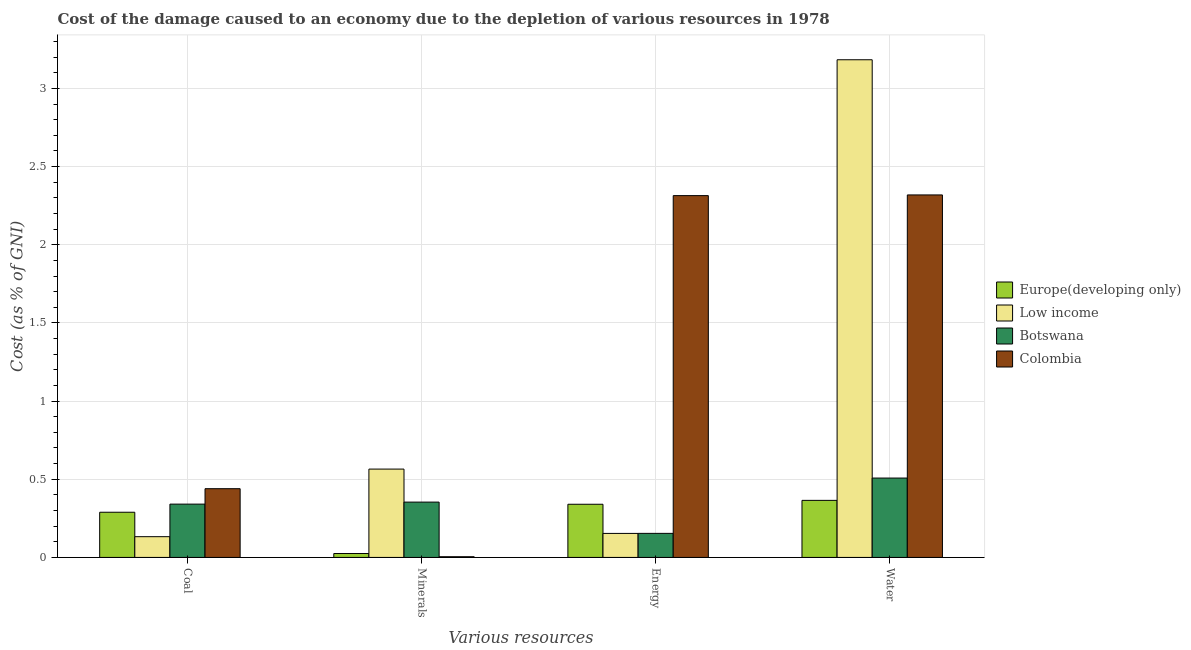How many groups of bars are there?
Offer a terse response. 4. Are the number of bars on each tick of the X-axis equal?
Your response must be concise. Yes. How many bars are there on the 4th tick from the right?
Provide a short and direct response. 4. What is the label of the 1st group of bars from the left?
Your response must be concise. Coal. What is the cost of damage due to depletion of energy in Low income?
Provide a succinct answer. 0.15. Across all countries, what is the maximum cost of damage due to depletion of water?
Provide a short and direct response. 3.18. Across all countries, what is the minimum cost of damage due to depletion of energy?
Provide a short and direct response. 0.15. In which country was the cost of damage due to depletion of energy maximum?
Ensure brevity in your answer.  Colombia. In which country was the cost of damage due to depletion of water minimum?
Provide a succinct answer. Europe(developing only). What is the total cost of damage due to depletion of coal in the graph?
Your answer should be very brief. 1.2. What is the difference between the cost of damage due to depletion of water in Botswana and that in Colombia?
Make the answer very short. -1.81. What is the difference between the cost of damage due to depletion of energy in Low income and the cost of damage due to depletion of coal in Europe(developing only)?
Keep it short and to the point. -0.14. What is the average cost of damage due to depletion of minerals per country?
Give a very brief answer. 0.24. What is the difference between the cost of damage due to depletion of water and cost of damage due to depletion of coal in Colombia?
Offer a terse response. 1.88. In how many countries, is the cost of damage due to depletion of energy greater than 1.1 %?
Provide a short and direct response. 1. What is the ratio of the cost of damage due to depletion of energy in Botswana to that in Colombia?
Your response must be concise. 0.07. Is the difference between the cost of damage due to depletion of minerals in Botswana and Europe(developing only) greater than the difference between the cost of damage due to depletion of water in Botswana and Europe(developing only)?
Your response must be concise. Yes. What is the difference between the highest and the second highest cost of damage due to depletion of water?
Offer a very short reply. 0.86. What is the difference between the highest and the lowest cost of damage due to depletion of energy?
Your answer should be compact. 2.16. In how many countries, is the cost of damage due to depletion of minerals greater than the average cost of damage due to depletion of minerals taken over all countries?
Provide a short and direct response. 2. What does the 3rd bar from the left in Water represents?
Your answer should be very brief. Botswana. What does the 2nd bar from the right in Water represents?
Make the answer very short. Botswana. Is it the case that in every country, the sum of the cost of damage due to depletion of coal and cost of damage due to depletion of minerals is greater than the cost of damage due to depletion of energy?
Offer a very short reply. No. How many bars are there?
Offer a terse response. 16. Are all the bars in the graph horizontal?
Make the answer very short. No. Does the graph contain any zero values?
Your answer should be compact. No. Does the graph contain grids?
Your answer should be very brief. Yes. Where does the legend appear in the graph?
Offer a terse response. Center right. How many legend labels are there?
Your answer should be very brief. 4. How are the legend labels stacked?
Your answer should be compact. Vertical. What is the title of the graph?
Provide a short and direct response. Cost of the damage caused to an economy due to the depletion of various resources in 1978 . What is the label or title of the X-axis?
Keep it short and to the point. Various resources. What is the label or title of the Y-axis?
Give a very brief answer. Cost (as % of GNI). What is the Cost (as % of GNI) of Europe(developing only) in Coal?
Your answer should be compact. 0.29. What is the Cost (as % of GNI) of Low income in Coal?
Your answer should be compact. 0.13. What is the Cost (as % of GNI) of Botswana in Coal?
Provide a short and direct response. 0.34. What is the Cost (as % of GNI) in Colombia in Coal?
Make the answer very short. 0.44. What is the Cost (as % of GNI) of Europe(developing only) in Minerals?
Provide a short and direct response. 0.02. What is the Cost (as % of GNI) of Low income in Minerals?
Provide a short and direct response. 0.57. What is the Cost (as % of GNI) of Botswana in Minerals?
Provide a short and direct response. 0.35. What is the Cost (as % of GNI) of Colombia in Minerals?
Your answer should be compact. 0. What is the Cost (as % of GNI) in Europe(developing only) in Energy?
Provide a short and direct response. 0.34. What is the Cost (as % of GNI) of Low income in Energy?
Offer a terse response. 0.15. What is the Cost (as % of GNI) of Botswana in Energy?
Offer a very short reply. 0.15. What is the Cost (as % of GNI) of Colombia in Energy?
Give a very brief answer. 2.31. What is the Cost (as % of GNI) of Europe(developing only) in Water?
Make the answer very short. 0.37. What is the Cost (as % of GNI) in Low income in Water?
Keep it short and to the point. 3.18. What is the Cost (as % of GNI) of Botswana in Water?
Your answer should be compact. 0.51. What is the Cost (as % of GNI) of Colombia in Water?
Provide a short and direct response. 2.32. Across all Various resources, what is the maximum Cost (as % of GNI) of Europe(developing only)?
Your answer should be very brief. 0.37. Across all Various resources, what is the maximum Cost (as % of GNI) of Low income?
Make the answer very short. 3.18. Across all Various resources, what is the maximum Cost (as % of GNI) of Botswana?
Provide a short and direct response. 0.51. Across all Various resources, what is the maximum Cost (as % of GNI) in Colombia?
Give a very brief answer. 2.32. Across all Various resources, what is the minimum Cost (as % of GNI) in Europe(developing only)?
Keep it short and to the point. 0.02. Across all Various resources, what is the minimum Cost (as % of GNI) in Low income?
Provide a succinct answer. 0.13. Across all Various resources, what is the minimum Cost (as % of GNI) in Botswana?
Offer a terse response. 0.15. Across all Various resources, what is the minimum Cost (as % of GNI) of Colombia?
Your response must be concise. 0. What is the total Cost (as % of GNI) of Europe(developing only) in the graph?
Offer a very short reply. 1.02. What is the total Cost (as % of GNI) of Low income in the graph?
Your answer should be very brief. 4.03. What is the total Cost (as % of GNI) in Botswana in the graph?
Ensure brevity in your answer.  1.36. What is the total Cost (as % of GNI) in Colombia in the graph?
Provide a short and direct response. 5.08. What is the difference between the Cost (as % of GNI) in Europe(developing only) in Coal and that in Minerals?
Your answer should be very brief. 0.26. What is the difference between the Cost (as % of GNI) of Low income in Coal and that in Minerals?
Make the answer very short. -0.43. What is the difference between the Cost (as % of GNI) in Botswana in Coal and that in Minerals?
Keep it short and to the point. -0.01. What is the difference between the Cost (as % of GNI) in Colombia in Coal and that in Minerals?
Give a very brief answer. 0.44. What is the difference between the Cost (as % of GNI) in Europe(developing only) in Coal and that in Energy?
Offer a very short reply. -0.05. What is the difference between the Cost (as % of GNI) of Low income in Coal and that in Energy?
Keep it short and to the point. -0.02. What is the difference between the Cost (as % of GNI) of Botswana in Coal and that in Energy?
Your answer should be very brief. 0.19. What is the difference between the Cost (as % of GNI) of Colombia in Coal and that in Energy?
Your answer should be very brief. -1.87. What is the difference between the Cost (as % of GNI) of Europe(developing only) in Coal and that in Water?
Provide a short and direct response. -0.08. What is the difference between the Cost (as % of GNI) in Low income in Coal and that in Water?
Your answer should be compact. -3.05. What is the difference between the Cost (as % of GNI) in Colombia in Coal and that in Water?
Ensure brevity in your answer.  -1.88. What is the difference between the Cost (as % of GNI) of Europe(developing only) in Minerals and that in Energy?
Ensure brevity in your answer.  -0.32. What is the difference between the Cost (as % of GNI) of Low income in Minerals and that in Energy?
Offer a terse response. 0.41. What is the difference between the Cost (as % of GNI) in Colombia in Minerals and that in Energy?
Make the answer very short. -2.31. What is the difference between the Cost (as % of GNI) in Europe(developing only) in Minerals and that in Water?
Your answer should be very brief. -0.34. What is the difference between the Cost (as % of GNI) in Low income in Minerals and that in Water?
Ensure brevity in your answer.  -2.62. What is the difference between the Cost (as % of GNI) in Botswana in Minerals and that in Water?
Your response must be concise. -0.15. What is the difference between the Cost (as % of GNI) of Colombia in Minerals and that in Water?
Keep it short and to the point. -2.31. What is the difference between the Cost (as % of GNI) in Europe(developing only) in Energy and that in Water?
Your answer should be very brief. -0.02. What is the difference between the Cost (as % of GNI) of Low income in Energy and that in Water?
Provide a succinct answer. -3.03. What is the difference between the Cost (as % of GNI) in Botswana in Energy and that in Water?
Your answer should be very brief. -0.35. What is the difference between the Cost (as % of GNI) of Colombia in Energy and that in Water?
Provide a succinct answer. -0. What is the difference between the Cost (as % of GNI) of Europe(developing only) in Coal and the Cost (as % of GNI) of Low income in Minerals?
Ensure brevity in your answer.  -0.28. What is the difference between the Cost (as % of GNI) in Europe(developing only) in Coal and the Cost (as % of GNI) in Botswana in Minerals?
Ensure brevity in your answer.  -0.06. What is the difference between the Cost (as % of GNI) in Europe(developing only) in Coal and the Cost (as % of GNI) in Colombia in Minerals?
Offer a terse response. 0.28. What is the difference between the Cost (as % of GNI) in Low income in Coal and the Cost (as % of GNI) in Botswana in Minerals?
Offer a terse response. -0.22. What is the difference between the Cost (as % of GNI) of Low income in Coal and the Cost (as % of GNI) of Colombia in Minerals?
Offer a terse response. 0.13. What is the difference between the Cost (as % of GNI) of Botswana in Coal and the Cost (as % of GNI) of Colombia in Minerals?
Your answer should be compact. 0.34. What is the difference between the Cost (as % of GNI) of Europe(developing only) in Coal and the Cost (as % of GNI) of Low income in Energy?
Give a very brief answer. 0.14. What is the difference between the Cost (as % of GNI) in Europe(developing only) in Coal and the Cost (as % of GNI) in Botswana in Energy?
Give a very brief answer. 0.14. What is the difference between the Cost (as % of GNI) of Europe(developing only) in Coal and the Cost (as % of GNI) of Colombia in Energy?
Your answer should be very brief. -2.03. What is the difference between the Cost (as % of GNI) of Low income in Coal and the Cost (as % of GNI) of Botswana in Energy?
Keep it short and to the point. -0.02. What is the difference between the Cost (as % of GNI) of Low income in Coal and the Cost (as % of GNI) of Colombia in Energy?
Provide a short and direct response. -2.18. What is the difference between the Cost (as % of GNI) in Botswana in Coal and the Cost (as % of GNI) in Colombia in Energy?
Offer a terse response. -1.97. What is the difference between the Cost (as % of GNI) of Europe(developing only) in Coal and the Cost (as % of GNI) of Low income in Water?
Give a very brief answer. -2.89. What is the difference between the Cost (as % of GNI) of Europe(developing only) in Coal and the Cost (as % of GNI) of Botswana in Water?
Provide a succinct answer. -0.22. What is the difference between the Cost (as % of GNI) in Europe(developing only) in Coal and the Cost (as % of GNI) in Colombia in Water?
Your response must be concise. -2.03. What is the difference between the Cost (as % of GNI) in Low income in Coal and the Cost (as % of GNI) in Botswana in Water?
Your response must be concise. -0.38. What is the difference between the Cost (as % of GNI) of Low income in Coal and the Cost (as % of GNI) of Colombia in Water?
Give a very brief answer. -2.19. What is the difference between the Cost (as % of GNI) of Botswana in Coal and the Cost (as % of GNI) of Colombia in Water?
Offer a very short reply. -1.98. What is the difference between the Cost (as % of GNI) in Europe(developing only) in Minerals and the Cost (as % of GNI) in Low income in Energy?
Your response must be concise. -0.13. What is the difference between the Cost (as % of GNI) in Europe(developing only) in Minerals and the Cost (as % of GNI) in Botswana in Energy?
Ensure brevity in your answer.  -0.13. What is the difference between the Cost (as % of GNI) of Europe(developing only) in Minerals and the Cost (as % of GNI) of Colombia in Energy?
Your answer should be very brief. -2.29. What is the difference between the Cost (as % of GNI) in Low income in Minerals and the Cost (as % of GNI) in Botswana in Energy?
Your answer should be compact. 0.41. What is the difference between the Cost (as % of GNI) in Low income in Minerals and the Cost (as % of GNI) in Colombia in Energy?
Make the answer very short. -1.75. What is the difference between the Cost (as % of GNI) in Botswana in Minerals and the Cost (as % of GNI) in Colombia in Energy?
Your response must be concise. -1.96. What is the difference between the Cost (as % of GNI) of Europe(developing only) in Minerals and the Cost (as % of GNI) of Low income in Water?
Your answer should be compact. -3.16. What is the difference between the Cost (as % of GNI) of Europe(developing only) in Minerals and the Cost (as % of GNI) of Botswana in Water?
Offer a terse response. -0.48. What is the difference between the Cost (as % of GNI) in Europe(developing only) in Minerals and the Cost (as % of GNI) in Colombia in Water?
Provide a succinct answer. -2.29. What is the difference between the Cost (as % of GNI) of Low income in Minerals and the Cost (as % of GNI) of Botswana in Water?
Provide a succinct answer. 0.06. What is the difference between the Cost (as % of GNI) of Low income in Minerals and the Cost (as % of GNI) of Colombia in Water?
Your answer should be compact. -1.75. What is the difference between the Cost (as % of GNI) in Botswana in Minerals and the Cost (as % of GNI) in Colombia in Water?
Your answer should be very brief. -1.96. What is the difference between the Cost (as % of GNI) in Europe(developing only) in Energy and the Cost (as % of GNI) in Low income in Water?
Ensure brevity in your answer.  -2.84. What is the difference between the Cost (as % of GNI) in Europe(developing only) in Energy and the Cost (as % of GNI) in Botswana in Water?
Keep it short and to the point. -0.17. What is the difference between the Cost (as % of GNI) of Europe(developing only) in Energy and the Cost (as % of GNI) of Colombia in Water?
Your answer should be compact. -1.98. What is the difference between the Cost (as % of GNI) of Low income in Energy and the Cost (as % of GNI) of Botswana in Water?
Your response must be concise. -0.35. What is the difference between the Cost (as % of GNI) in Low income in Energy and the Cost (as % of GNI) in Colombia in Water?
Keep it short and to the point. -2.17. What is the difference between the Cost (as % of GNI) in Botswana in Energy and the Cost (as % of GNI) in Colombia in Water?
Offer a very short reply. -2.16. What is the average Cost (as % of GNI) in Europe(developing only) per Various resources?
Provide a succinct answer. 0.25. What is the average Cost (as % of GNI) of Low income per Various resources?
Give a very brief answer. 1.01. What is the average Cost (as % of GNI) of Botswana per Various resources?
Your response must be concise. 0.34. What is the average Cost (as % of GNI) in Colombia per Various resources?
Keep it short and to the point. 1.27. What is the difference between the Cost (as % of GNI) in Europe(developing only) and Cost (as % of GNI) in Low income in Coal?
Ensure brevity in your answer.  0.16. What is the difference between the Cost (as % of GNI) of Europe(developing only) and Cost (as % of GNI) of Botswana in Coal?
Provide a succinct answer. -0.05. What is the difference between the Cost (as % of GNI) of Europe(developing only) and Cost (as % of GNI) of Colombia in Coal?
Offer a very short reply. -0.15. What is the difference between the Cost (as % of GNI) in Low income and Cost (as % of GNI) in Botswana in Coal?
Offer a terse response. -0.21. What is the difference between the Cost (as % of GNI) in Low income and Cost (as % of GNI) in Colombia in Coal?
Keep it short and to the point. -0.31. What is the difference between the Cost (as % of GNI) of Botswana and Cost (as % of GNI) of Colombia in Coal?
Keep it short and to the point. -0.1. What is the difference between the Cost (as % of GNI) of Europe(developing only) and Cost (as % of GNI) of Low income in Minerals?
Provide a succinct answer. -0.54. What is the difference between the Cost (as % of GNI) of Europe(developing only) and Cost (as % of GNI) of Botswana in Minerals?
Your answer should be very brief. -0.33. What is the difference between the Cost (as % of GNI) of Europe(developing only) and Cost (as % of GNI) of Colombia in Minerals?
Offer a very short reply. 0.02. What is the difference between the Cost (as % of GNI) in Low income and Cost (as % of GNI) in Botswana in Minerals?
Your answer should be very brief. 0.21. What is the difference between the Cost (as % of GNI) in Low income and Cost (as % of GNI) in Colombia in Minerals?
Keep it short and to the point. 0.56. What is the difference between the Cost (as % of GNI) of Botswana and Cost (as % of GNI) of Colombia in Minerals?
Give a very brief answer. 0.35. What is the difference between the Cost (as % of GNI) of Europe(developing only) and Cost (as % of GNI) of Low income in Energy?
Offer a terse response. 0.19. What is the difference between the Cost (as % of GNI) in Europe(developing only) and Cost (as % of GNI) in Botswana in Energy?
Offer a terse response. 0.19. What is the difference between the Cost (as % of GNI) in Europe(developing only) and Cost (as % of GNI) in Colombia in Energy?
Your response must be concise. -1.97. What is the difference between the Cost (as % of GNI) of Low income and Cost (as % of GNI) of Botswana in Energy?
Your answer should be very brief. -0. What is the difference between the Cost (as % of GNI) in Low income and Cost (as % of GNI) in Colombia in Energy?
Your response must be concise. -2.16. What is the difference between the Cost (as % of GNI) of Botswana and Cost (as % of GNI) of Colombia in Energy?
Provide a short and direct response. -2.16. What is the difference between the Cost (as % of GNI) in Europe(developing only) and Cost (as % of GNI) in Low income in Water?
Give a very brief answer. -2.82. What is the difference between the Cost (as % of GNI) of Europe(developing only) and Cost (as % of GNI) of Botswana in Water?
Your answer should be very brief. -0.14. What is the difference between the Cost (as % of GNI) of Europe(developing only) and Cost (as % of GNI) of Colombia in Water?
Make the answer very short. -1.95. What is the difference between the Cost (as % of GNI) in Low income and Cost (as % of GNI) in Botswana in Water?
Provide a short and direct response. 2.68. What is the difference between the Cost (as % of GNI) of Low income and Cost (as % of GNI) of Colombia in Water?
Ensure brevity in your answer.  0.86. What is the difference between the Cost (as % of GNI) in Botswana and Cost (as % of GNI) in Colombia in Water?
Keep it short and to the point. -1.81. What is the ratio of the Cost (as % of GNI) in Europe(developing only) in Coal to that in Minerals?
Ensure brevity in your answer.  11.59. What is the ratio of the Cost (as % of GNI) in Low income in Coal to that in Minerals?
Offer a terse response. 0.23. What is the ratio of the Cost (as % of GNI) of Botswana in Coal to that in Minerals?
Your answer should be compact. 0.96. What is the ratio of the Cost (as % of GNI) of Colombia in Coal to that in Minerals?
Keep it short and to the point. 99.1. What is the ratio of the Cost (as % of GNI) in Europe(developing only) in Coal to that in Energy?
Offer a very short reply. 0.85. What is the ratio of the Cost (as % of GNI) of Low income in Coal to that in Energy?
Your answer should be very brief. 0.86. What is the ratio of the Cost (as % of GNI) of Botswana in Coal to that in Energy?
Offer a very short reply. 2.22. What is the ratio of the Cost (as % of GNI) of Colombia in Coal to that in Energy?
Give a very brief answer. 0.19. What is the ratio of the Cost (as % of GNI) in Europe(developing only) in Coal to that in Water?
Your answer should be very brief. 0.79. What is the ratio of the Cost (as % of GNI) of Low income in Coal to that in Water?
Provide a short and direct response. 0.04. What is the ratio of the Cost (as % of GNI) in Botswana in Coal to that in Water?
Keep it short and to the point. 0.67. What is the ratio of the Cost (as % of GNI) in Colombia in Coal to that in Water?
Provide a succinct answer. 0.19. What is the ratio of the Cost (as % of GNI) in Europe(developing only) in Minerals to that in Energy?
Your answer should be very brief. 0.07. What is the ratio of the Cost (as % of GNI) in Low income in Minerals to that in Energy?
Give a very brief answer. 3.68. What is the ratio of the Cost (as % of GNI) of Botswana in Minerals to that in Energy?
Make the answer very short. 2.3. What is the ratio of the Cost (as % of GNI) in Colombia in Minerals to that in Energy?
Keep it short and to the point. 0. What is the ratio of the Cost (as % of GNI) of Europe(developing only) in Minerals to that in Water?
Offer a very short reply. 0.07. What is the ratio of the Cost (as % of GNI) in Low income in Minerals to that in Water?
Provide a short and direct response. 0.18. What is the ratio of the Cost (as % of GNI) in Botswana in Minerals to that in Water?
Keep it short and to the point. 0.7. What is the ratio of the Cost (as % of GNI) of Colombia in Minerals to that in Water?
Keep it short and to the point. 0. What is the ratio of the Cost (as % of GNI) of Europe(developing only) in Energy to that in Water?
Offer a terse response. 0.93. What is the ratio of the Cost (as % of GNI) of Low income in Energy to that in Water?
Give a very brief answer. 0.05. What is the ratio of the Cost (as % of GNI) of Botswana in Energy to that in Water?
Ensure brevity in your answer.  0.3. What is the difference between the highest and the second highest Cost (as % of GNI) of Europe(developing only)?
Your response must be concise. 0.02. What is the difference between the highest and the second highest Cost (as % of GNI) of Low income?
Offer a very short reply. 2.62. What is the difference between the highest and the second highest Cost (as % of GNI) in Botswana?
Make the answer very short. 0.15. What is the difference between the highest and the second highest Cost (as % of GNI) in Colombia?
Ensure brevity in your answer.  0. What is the difference between the highest and the lowest Cost (as % of GNI) of Europe(developing only)?
Your answer should be compact. 0.34. What is the difference between the highest and the lowest Cost (as % of GNI) in Low income?
Offer a terse response. 3.05. What is the difference between the highest and the lowest Cost (as % of GNI) of Botswana?
Your answer should be very brief. 0.35. What is the difference between the highest and the lowest Cost (as % of GNI) in Colombia?
Your answer should be compact. 2.31. 